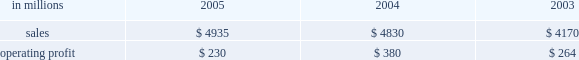Entering 2006 , earnings in the first quarter are ex- pected to improve compared with the 2005 fourth quar- ter due principally to higher average price realizations , reflecting announced price increases .
Product demand for the first quarter should be seasonally slow , but is ex- pected to strengthen as the year progresses , supported by continued economic growth in north america , asia and eastern europe .
Average prices should also improve in 2006 as price increases announced in late 2005 and early 2006 for uncoated freesheet paper and pulp con- tinue to be realized .
Operating rates are expected to improve as a result of industry-wide capacity reductions in 2005 .
Although energy and raw material costs remain high , there has been some decline in both natural gas and delivered wood costs , with further moderation ex- pected later in 2006 .
We will continue to focus on fur- ther improvements in our global manufacturing operations , implementation of supply chain enhance- ments and reductions in overhead costs during 2006 .
Industrial packaging demand for industrial packaging products is closely correlated with non-durable industrial goods production in the united states , as well as with demand for proc- essed foods , poultry , meat and agricultural products .
In addition to prices and volumes , major factors affecting the profitability of industrial packaging are raw material and energy costs , manufacturing efficiency and product industrial packaging 2019s net sales for 2005 increased 2% ( 2 % ) compared with 2004 , and were 18% ( 18 % ) higher than in 2003 , reflecting the inclusion of international paper distribution limited ( formerly international paper pacific millennium limited ) beginning in august 2005 .
Operating profits in 2005 were 39% ( 39 % ) lower than in 2004 and 13% ( 13 % ) lower than in 2003 .
Sales volume increases ( $ 24 million ) , improved price realizations ( $ 66 million ) , and strong mill operating performance ( $ 27 million ) were not enough to offset the effects of increased raw material costs ( $ 103 million ) , higher market related downtime costs ( $ 50 million ) , higher converting operating costs ( $ 22 million ) , and unfavorable mix and other costs ( $ 67 million ) .
Additionally , the may 2005 sale of our industrial papers business resulted in a $ 25 million lower earnings contribution from this business in 2005 .
The segment took 370000 tons of downtime in 2005 , including 230000 tons of lack-of-order downtime to balance internal supply with customer demand , com- pared to a total of 170000 tons in 2004 , which included 5000 tons of lack-of-order downtime .
Industrial packaging in millions 2005 2004 2003 .
Containerboard 2019s net sales totaled $ 895 million in 2005 , $ 951 million in 2004 and $ 815 million in 2003 .
Soft market conditions and declining customer demand at the end of the first quarter led to lower average sales prices during the second and third quarters .
Beginning in the fourth quarter , prices recovered as a result of in- creased customer demand and a rationalization of sup- ply .
Full year sales volumes trailed 2004 levels early in the year , reflecting the weak market conditions in the first half of 2005 .
However , volumes rebounded in the second half of the year , and finished the year ahead of 2004 levels .
Operating profits decreased 38% ( 38 % ) from 2004 , but were flat with 2003 .
The favorable impacts of in- creased sales volumes , higher average sales prices and improved mill operating performance were not enough to offset the impact of higher wood , energy and other raw material costs and increased lack-of-order down- time .
Implementation of the new supply chain operating model in our containerboard mills during 2005 resulted in increased operating efficiency and cost savings .
Specialty papers in 2005 included the kraft paper business for the full year and the industrial papers busi- ness for five months prior to its sale in may 2005 .
Net sales totaled $ 468 million in 2005 , $ 723 million in 2004 and $ 690 million in 2003 .
Operating profits in 2005 were down 23% ( 23 % ) compared with 2004 and 54% ( 54 % ) com- pared with 2003 , reflecting the lower contribution from industrial papers .
U.s .
Converting operations net sales for 2005 were $ 2.6 billion compared with $ 2.3 billion in 2004 and $ 1.9 billion in 2003 .
Sales volumes were up 10% ( 10 % ) in 2005 compared with 2004 , mainly due to the acquisition of box usa in july 2004 .
Average sales prices in 2005 began the year above 2004 levels , but softened in the second half of the year .
Operating profits in 2005 de- creased 46% ( 46 % ) and 4% ( 4 % ) from 2004 and 2003 levels , re- spectively , primarily due to increased linerboard , freight and energy costs .
European container sales for 2005 were $ 883 mil- lion compared with $ 865 million in 2004 and $ 801 mil- lion in 2003 .
Operating profits declined 19% ( 19 % ) and 13% ( 13 % ) compared with 2004 and 2003 , respectively .
The in- crease in sales in 2005 reflected a slight increase in de- mand over 2004 , but this was not sufficient to offset the negative earnings effect of increased operating costs , unfavorable foreign exchange rates and a reduction in average sales prices .
The moroccan box plant acquis- ition , which was completed in october 2005 , favorably impacted fourth-quarter results .
Industrial packaging 2019s sales in 2005 included $ 104 million from international paper distribution limited , our asian box and containerboard business , subsequent to the acquisition of an additional 50% ( 50 % ) interest in au- gust 2005. .
Containerboards net sales represented what percentage of industrial packaging sales in 2005? 
Computations: (895 / 4935)
Answer: 0.18136. 